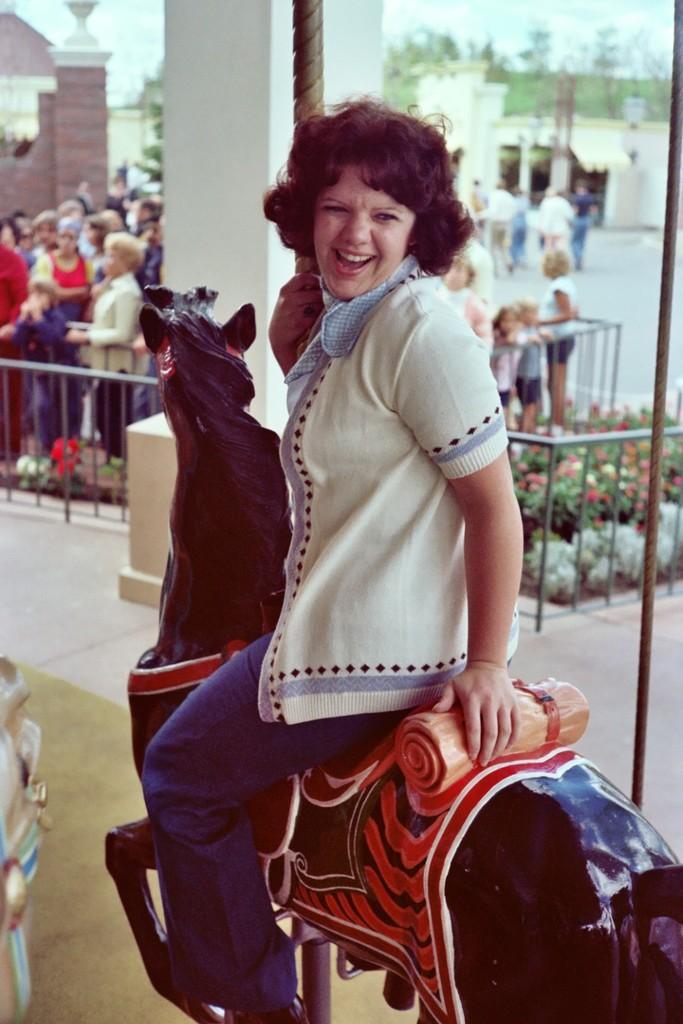Can you describe this image briefly? In the center of the image there is a lady sitting on a horse toy. In the background there are people standing. There are bushes, trees, sky, building in the background. 